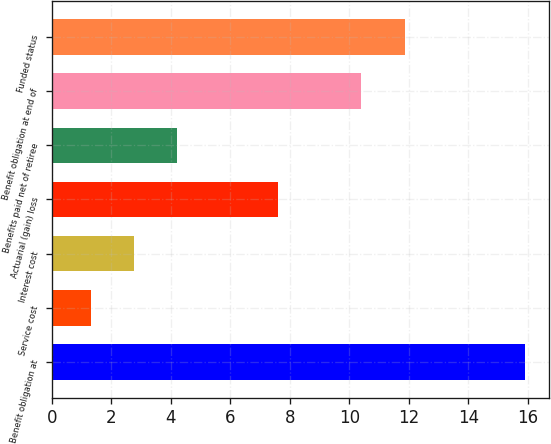Convert chart. <chart><loc_0><loc_0><loc_500><loc_500><bar_chart><fcel>Benefit obligation at<fcel>Service cost<fcel>Interest cost<fcel>Actuarial (gain) loss<fcel>Benefits paid net of retiree<fcel>Benefit obligation at end of<fcel>Funded status<nl><fcel>15.9<fcel>1.3<fcel>2.76<fcel>7.6<fcel>4.22<fcel>10.4<fcel>11.86<nl></chart> 